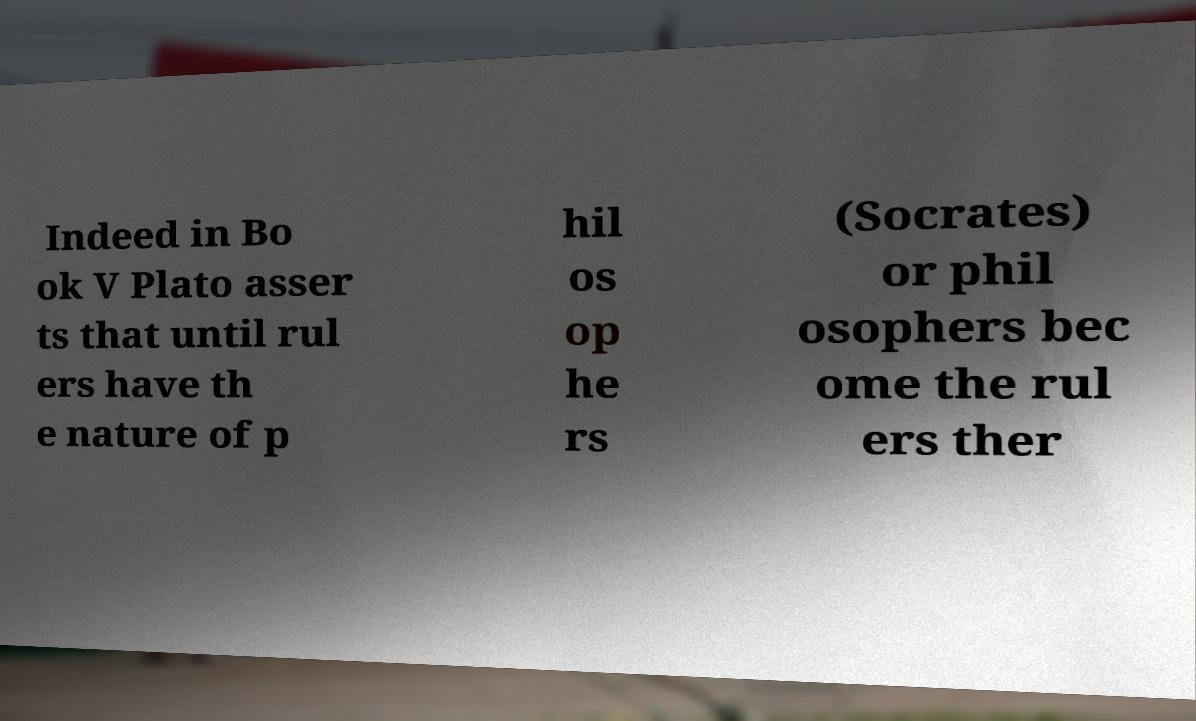Could you assist in decoding the text presented in this image and type it out clearly? Indeed in Bo ok V Plato asser ts that until rul ers have th e nature of p hil os op he rs (Socrates) or phil osophers bec ome the rul ers ther 